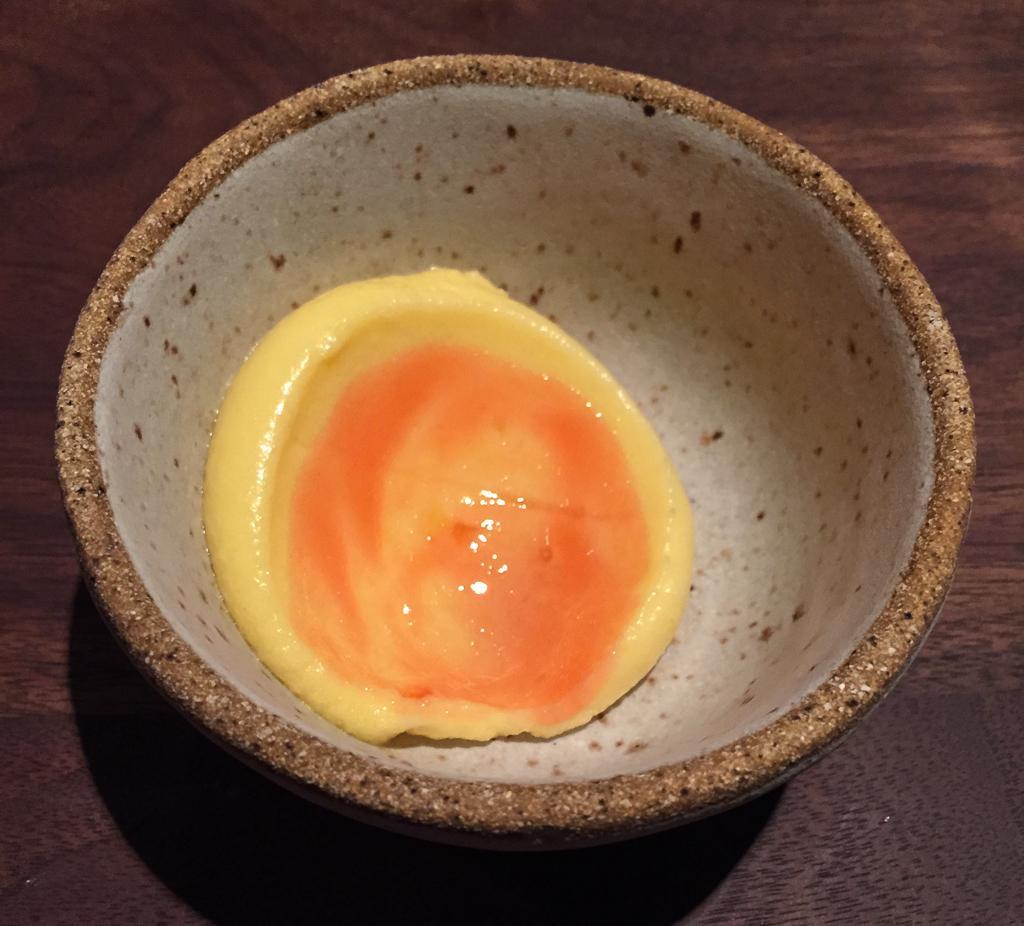Please provide a concise description of this image. In this image I can see some food item in the bowl. 